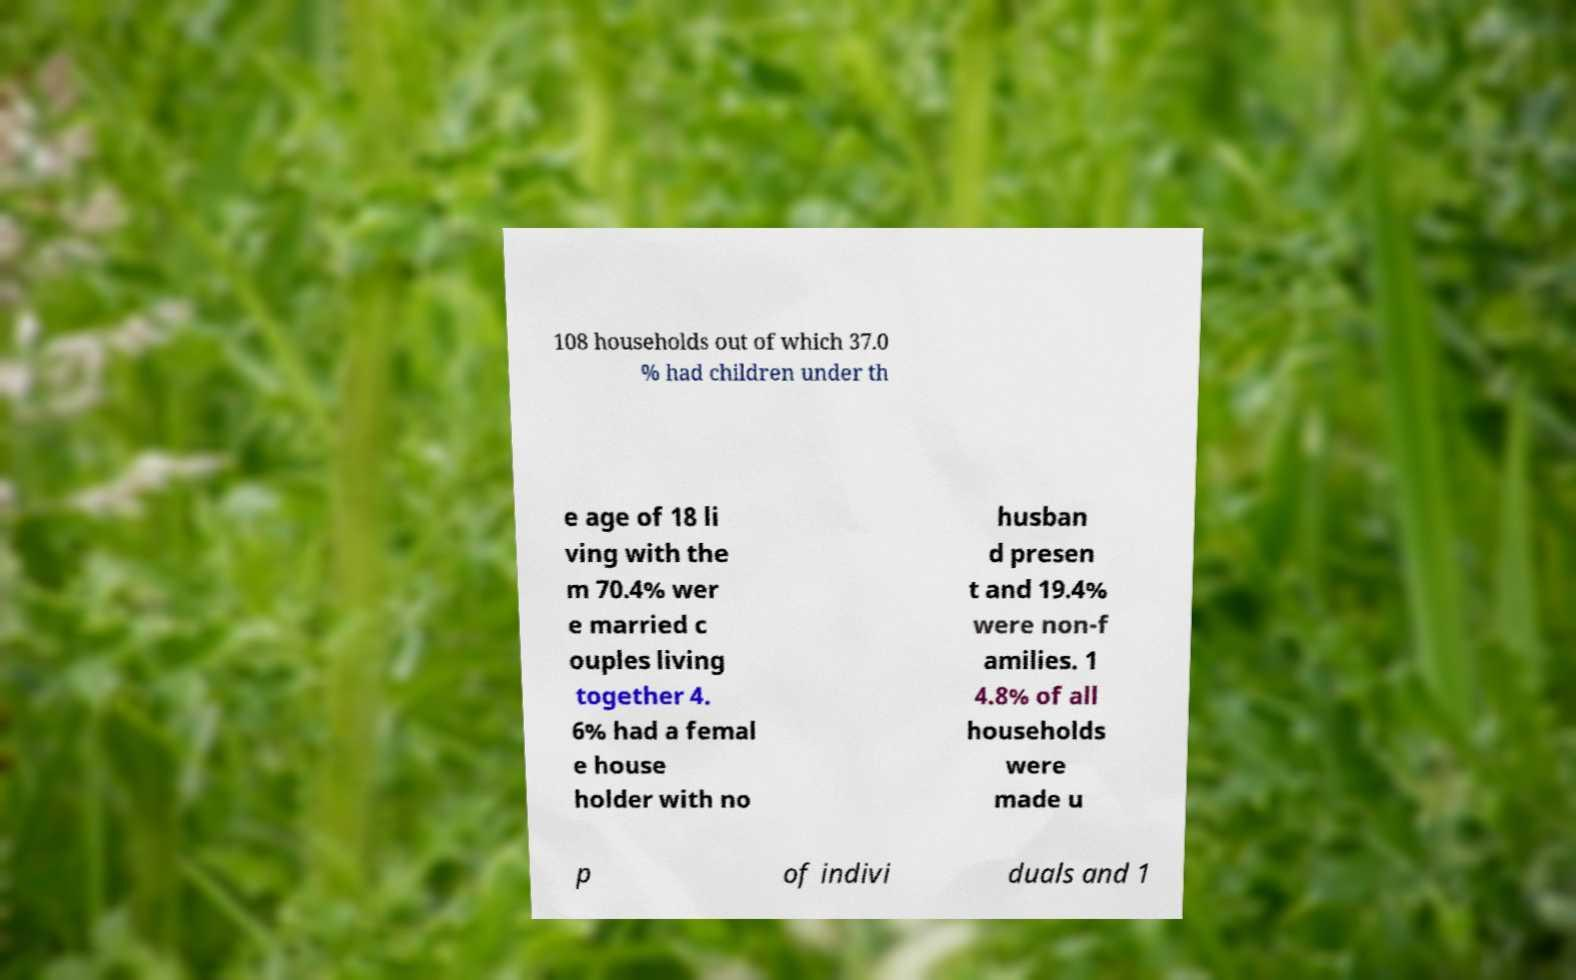Can you accurately transcribe the text from the provided image for me? 108 households out of which 37.0 % had children under th e age of 18 li ving with the m 70.4% wer e married c ouples living together 4. 6% had a femal e house holder with no husban d presen t and 19.4% were non-f amilies. 1 4.8% of all households were made u p of indivi duals and 1 